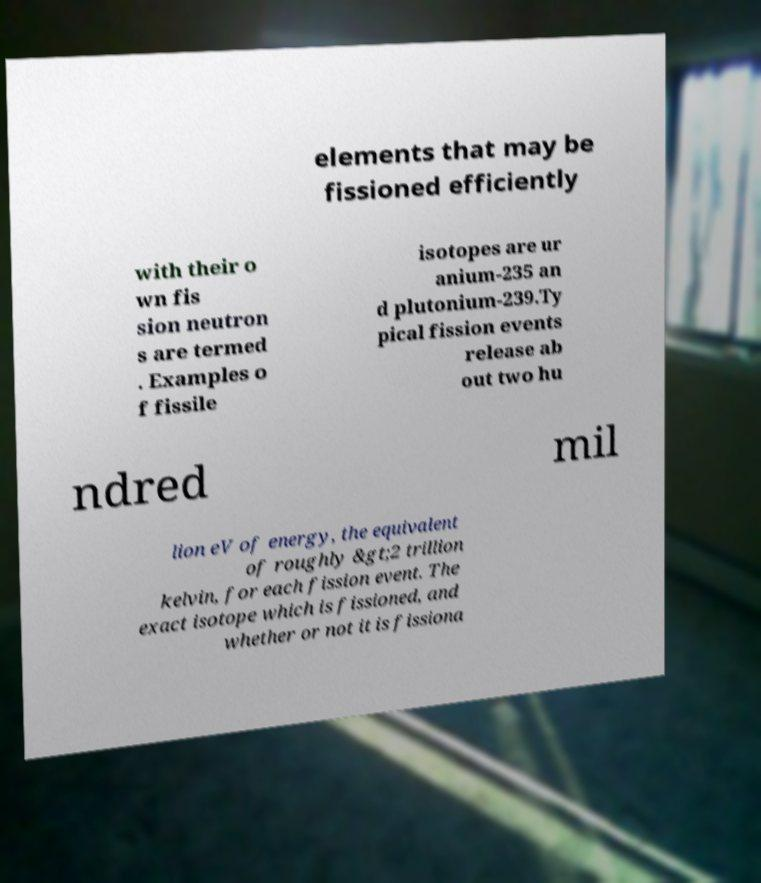For documentation purposes, I need the text within this image transcribed. Could you provide that? elements that may be fissioned efficiently with their o wn fis sion neutron s are termed . Examples o f fissile isotopes are ur anium-235 an d plutonium-239.Ty pical fission events release ab out two hu ndred mil lion eV of energy, the equivalent of roughly &gt;2 trillion kelvin, for each fission event. The exact isotope which is fissioned, and whether or not it is fissiona 